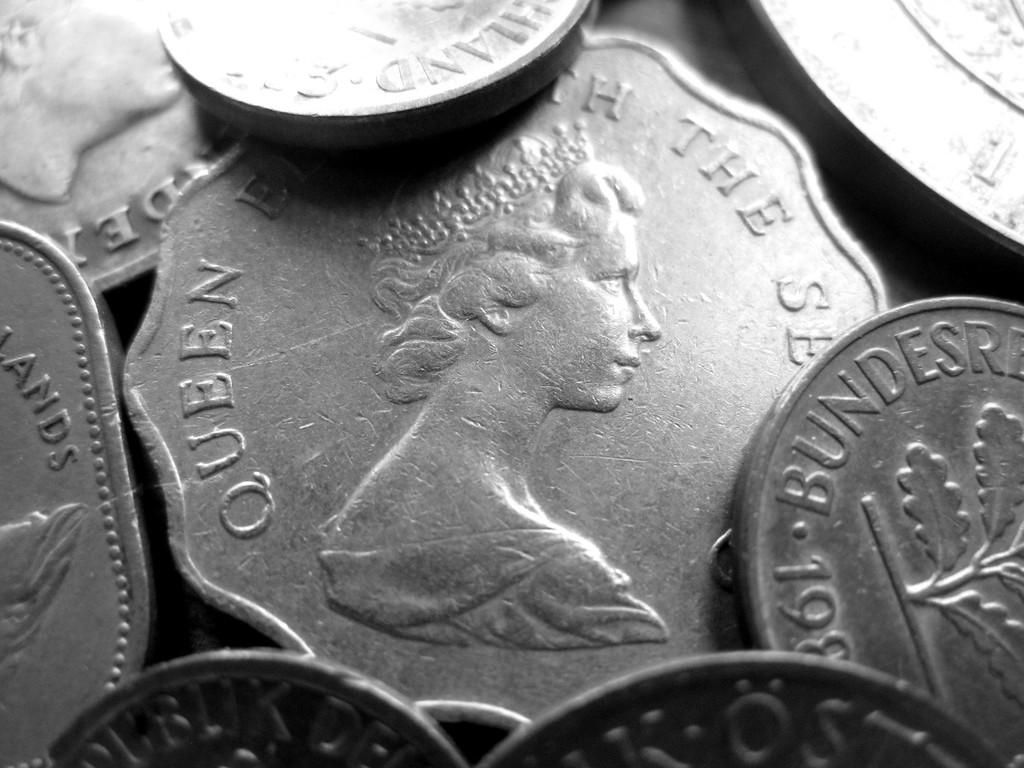<image>
Create a compact narrative representing the image presented. A pile of silver coins that say Bundersre and feature a queen. 